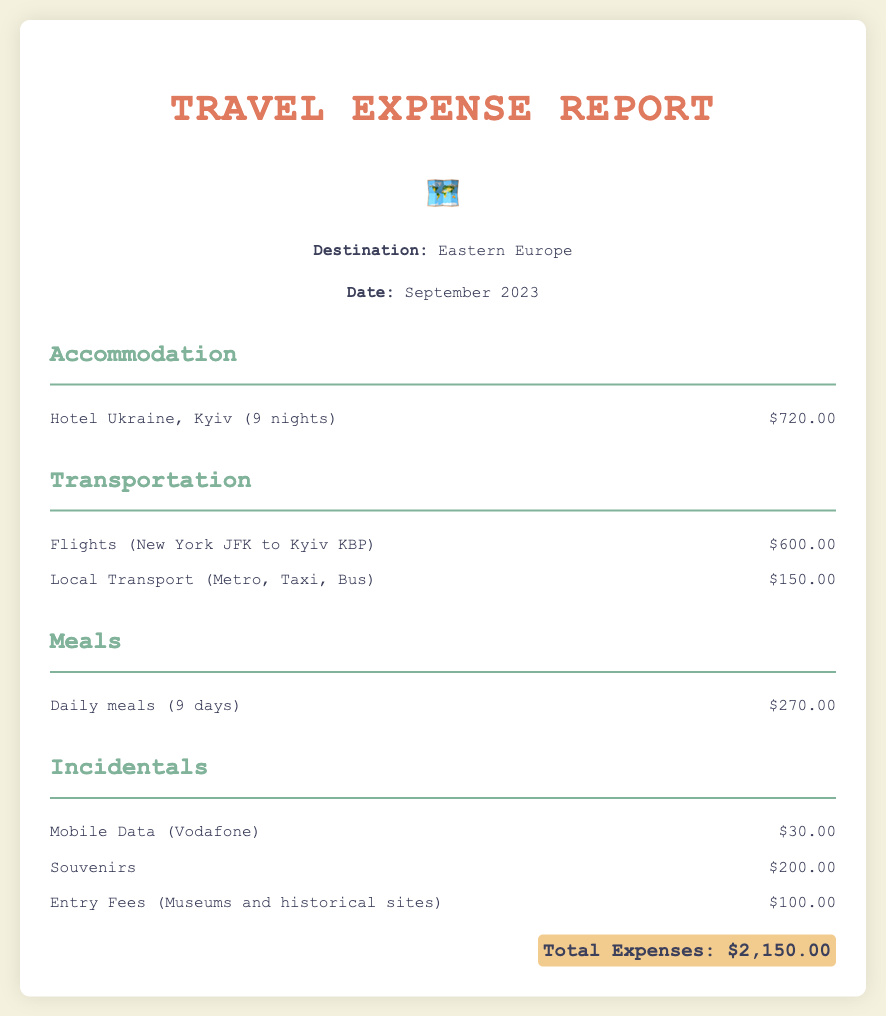What is the total amount spent on accommodation? The accommodation expense for the hotel is listed as $720.00 in the document.
Answer: $720.00 How many nights was the stay in Kyiv? The document states that the stay at Hotel Ukraine was for 9 nights.
Answer: 9 nights What was the cost of flights from New York to Kyiv? The total cost for flights from New York JFK to Kyiv KBP is given as $600.00.
Answer: $600.00 How much was spent on daily meals? The expense for daily meals over 9 days is specified as $270.00.
Answer: $270.00 What is the total amount for incidentals? The incidentals include mobile data, souvenirs, and entry fees, adding up to $330.00.
Answer: $330.00 Which city was the destination for the trip? The trip's destination is mentioned as Eastern Europe, specifically Kyiv, Ukraine.
Answer: Kyiv What was the cost for local transportation? The document lists the local transport expenses as $150.00.
Answer: $150.00 What is the total amount of all expenses combined? The total expenses, calculated from all sections, amount to $2,150.00.
Answer: $2,150.00 What type of report is this document? The document is a travel expense report detailing various costs during a trip.
Answer: Travel expense report 